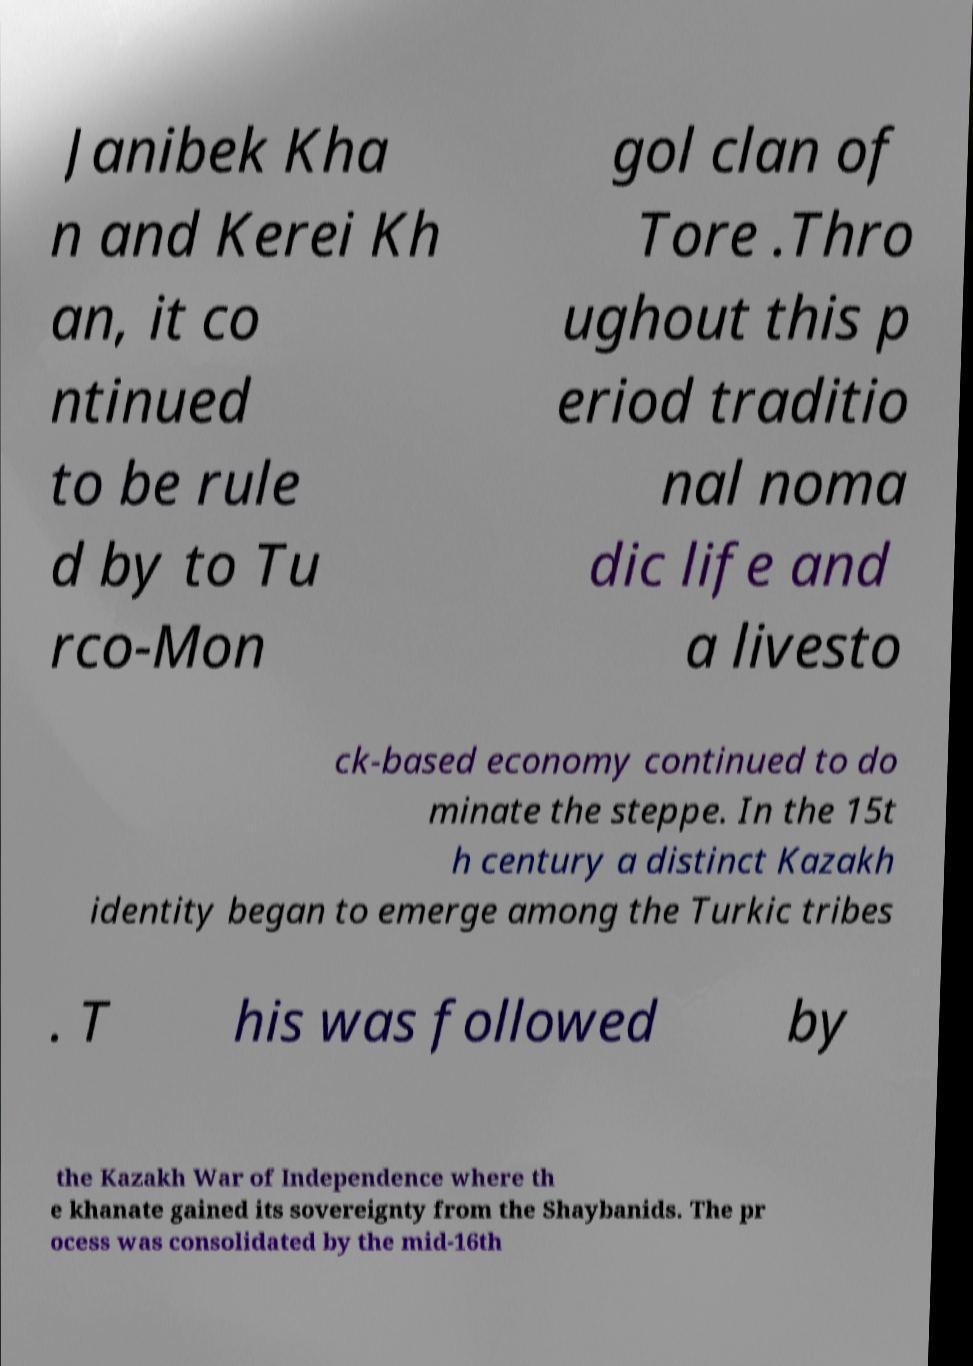Could you assist in decoding the text presented in this image and type it out clearly? Janibek Kha n and Kerei Kh an, it co ntinued to be rule d by to Tu rco-Mon gol clan of Tore .Thro ughout this p eriod traditio nal noma dic life and a livesto ck-based economy continued to do minate the steppe. In the 15t h century a distinct Kazakh identity began to emerge among the Turkic tribes . T his was followed by the Kazakh War of Independence where th e khanate gained its sovereignty from the Shaybanids. The pr ocess was consolidated by the mid-16th 